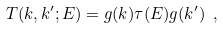<formula> <loc_0><loc_0><loc_500><loc_500>T ( k , k ^ { \prime } ; E ) = g ( k ) \tau ( E ) g ( k ^ { \prime } ) \ ,</formula> 